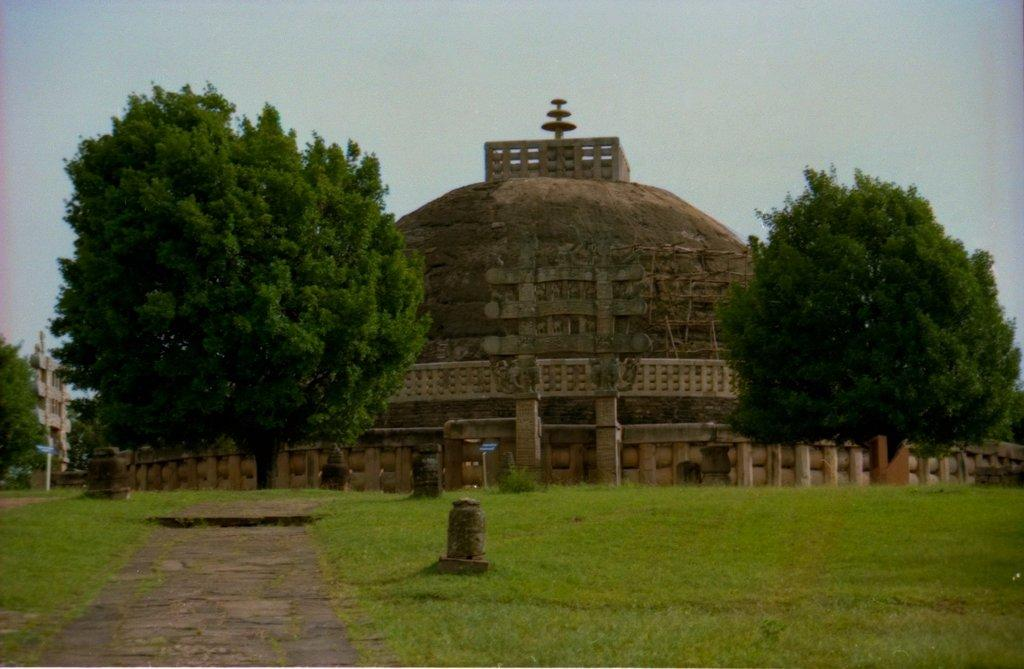What can be seen in the center of the image? The sky is visible in the center of the image. What type of structures are present in the image? There are buildings in the image. What type of barriers are visible in the image? Fences are present in the image. What type of vertical structures can be seen in the image? Poles are visible in the image. What type of vegetation is present in the image? Trees and grass are present in the image. What other objects can be seen in the image? There are a few other objects in the image. What type of pen is being used to write on the crown in the image? There is no pen or crown present in the image. 